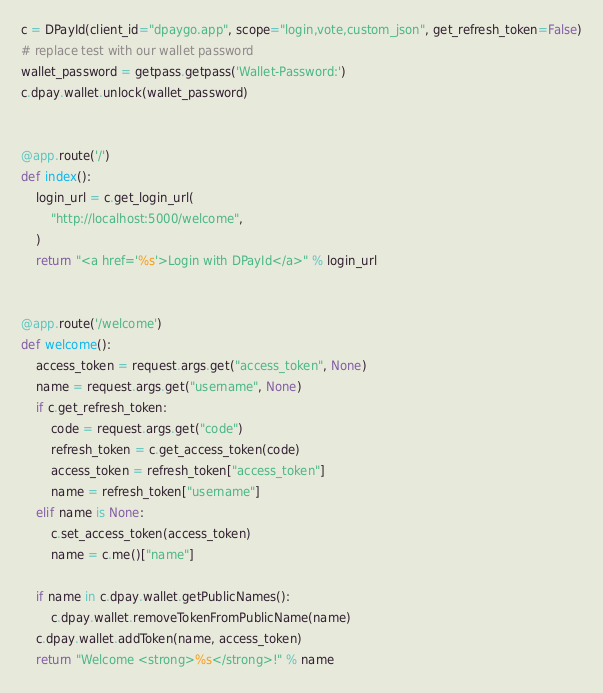Convert code to text. <code><loc_0><loc_0><loc_500><loc_500><_Python_>

c = DPayId(client_id="dpaygo.app", scope="login,vote,custom_json", get_refresh_token=False)
# replace test with our wallet password
wallet_password = getpass.getpass('Wallet-Password:')
c.dpay.wallet.unlock(wallet_password)


@app.route('/')
def index():
    login_url = c.get_login_url(
        "http://localhost:5000/welcome",
    )
    return "<a href='%s'>Login with DPayId</a>" % login_url


@app.route('/welcome')
def welcome():
    access_token = request.args.get("access_token", None)
    name = request.args.get("username", None)
    if c.get_refresh_token:
        code = request.args.get("code")
        refresh_token = c.get_access_token(code)
        access_token = refresh_token["access_token"]
        name = refresh_token["username"]
    elif name is None:
        c.set_access_token(access_token)
        name = c.me()["name"]

    if name in c.dpay.wallet.getPublicNames():
        c.dpay.wallet.removeTokenFromPublicName(name)
    c.dpay.wallet.addToken(name, access_token)
    return "Welcome <strong>%s</strong>!" % name
</code> 